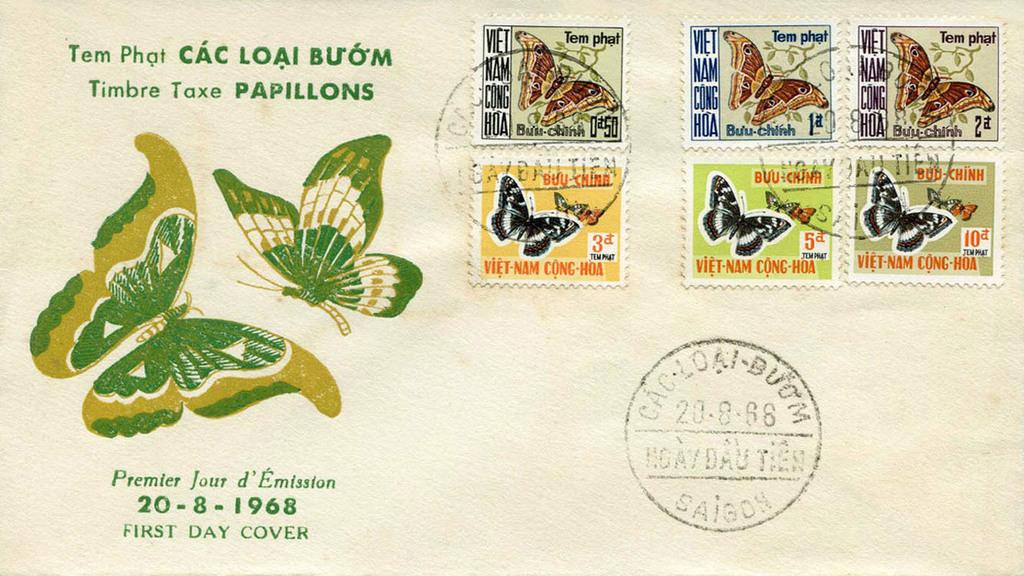What is on the paper in the image? There are butterfly stickers on the paper. What other object can be seen in the image? There is a stamp in the image. What is depicted on the stamp? Butterflies are depicted on the stamp. Is there any text or writing on the stamp? Yes, something is written on the stamp. What type of underwear is hanging on the wall in the image? There is no underwear present in the image. Can you tell me how many notes are attached to the butterfly stickers? There are no notes attached to the butterfly stickers in the image. 